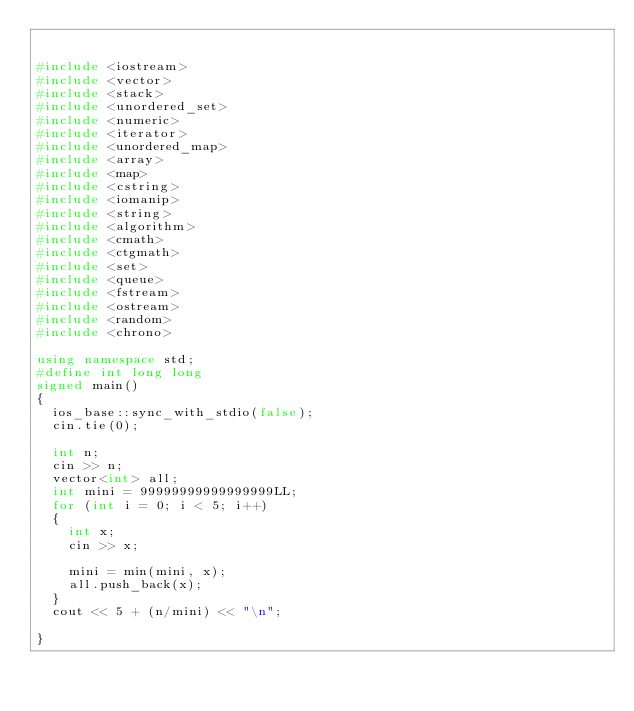<code> <loc_0><loc_0><loc_500><loc_500><_C++_>

#include <iostream>
#include <vector>
#include <stack>
#include <unordered_set>
#include <numeric>
#include <iterator>
#include <unordered_map>
#include <array>
#include <map>
#include <cstring>
#include <iomanip>
#include <string>
#include <algorithm>
#include <cmath>
#include <ctgmath>
#include <set>
#include <queue>
#include <fstream>
#include <ostream>
#include <random>
#include <chrono>

using namespace std;
#define int long long
signed main()
{
	ios_base::sync_with_stdio(false);
	cin.tie(0);
	
	int n;
	cin >> n;
	vector<int> all;
	int mini = 99999999999999999LL;
	for (int i = 0; i < 5; i++)
	{
		int x;
		cin >> x;

		mini = min(mini, x);
		all.push_back(x);
	}
	cout << 5 + (n/mini) << "\n";
	
}
</code> 